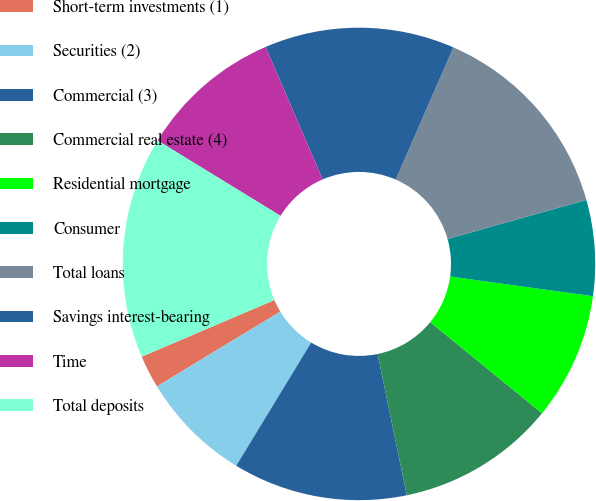Convert chart to OTSL. <chart><loc_0><loc_0><loc_500><loc_500><pie_chart><fcel>Short-term investments (1)<fcel>Securities (2)<fcel>Commercial (3)<fcel>Commercial real estate (4)<fcel>Residential mortgage<fcel>Consumer<fcel>Total loans<fcel>Savings interest-bearing<fcel>Time<fcel>Total deposits<nl><fcel>2.25%<fcel>7.63%<fcel>11.94%<fcel>10.86%<fcel>8.71%<fcel>6.55%<fcel>14.09%<fcel>13.01%<fcel>9.78%<fcel>15.17%<nl></chart> 